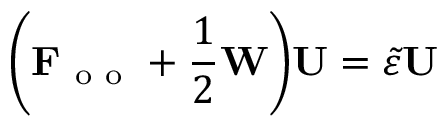Convert formula to latex. <formula><loc_0><loc_0><loc_500><loc_500>\left ( F _ { o o } + \frac { 1 } { 2 } W \right ) U = \tilde { \varepsilon } U</formula> 